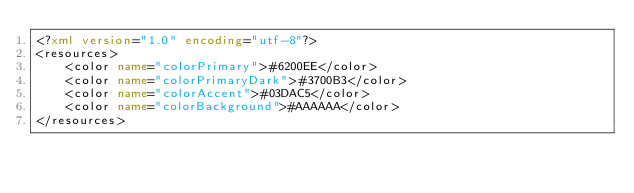<code> <loc_0><loc_0><loc_500><loc_500><_XML_><?xml version="1.0" encoding="utf-8"?>
<resources>
    <color name="colorPrimary">#6200EE</color>
    <color name="colorPrimaryDark">#3700B3</color>
    <color name="colorAccent">#03DAC5</color>
    <color name="colorBackground">#AAAAAA</color>
</resources>
</code> 